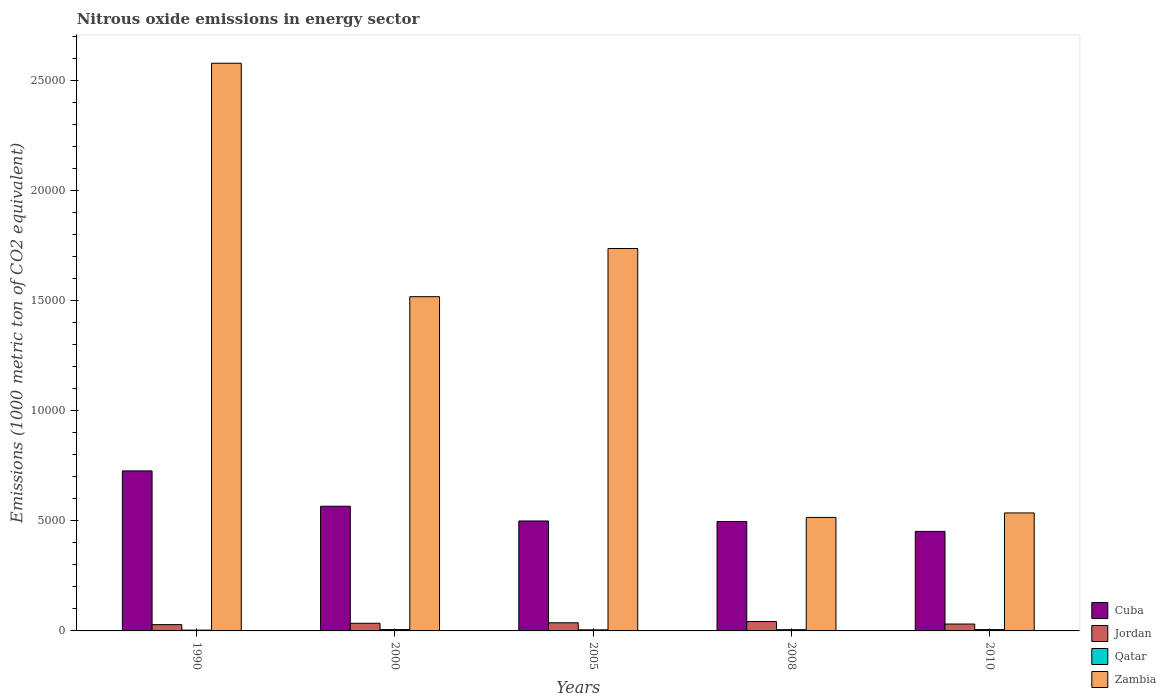How many different coloured bars are there?
Ensure brevity in your answer.  4. How many groups of bars are there?
Your answer should be compact. 5. Are the number of bars per tick equal to the number of legend labels?
Give a very brief answer. Yes. What is the label of the 2nd group of bars from the left?
Provide a short and direct response. 2000. What is the amount of nitrous oxide emitted in Cuba in 2005?
Give a very brief answer. 4992.1. Across all years, what is the maximum amount of nitrous oxide emitted in Zambia?
Provide a succinct answer. 2.58e+04. Across all years, what is the minimum amount of nitrous oxide emitted in Cuba?
Offer a very short reply. 4519.3. What is the total amount of nitrous oxide emitted in Jordan in the graph?
Your answer should be very brief. 1741.4. What is the difference between the amount of nitrous oxide emitted in Cuba in 2000 and that in 2008?
Give a very brief answer. 694.3. What is the difference between the amount of nitrous oxide emitted in Qatar in 2000 and the amount of nitrous oxide emitted in Zambia in 1990?
Provide a short and direct response. -2.57e+04. What is the average amount of nitrous oxide emitted in Qatar per year?
Offer a very short reply. 52.94. In the year 2005, what is the difference between the amount of nitrous oxide emitted in Jordan and amount of nitrous oxide emitted in Qatar?
Offer a terse response. 319.6. What is the ratio of the amount of nitrous oxide emitted in Zambia in 1990 to that in 2008?
Your answer should be compact. 5. What is the difference between the highest and the second highest amount of nitrous oxide emitted in Cuba?
Give a very brief answer. 1604.6. What is the difference between the highest and the lowest amount of nitrous oxide emitted in Cuba?
Your response must be concise. 2746.6. In how many years, is the amount of nitrous oxide emitted in Cuba greater than the average amount of nitrous oxide emitted in Cuba taken over all years?
Provide a succinct answer. 2. What does the 4th bar from the left in 2000 represents?
Ensure brevity in your answer.  Zambia. What does the 4th bar from the right in 2000 represents?
Your answer should be very brief. Cuba. How many bars are there?
Offer a very short reply. 20. Are all the bars in the graph horizontal?
Your answer should be compact. No. What is the difference between two consecutive major ticks on the Y-axis?
Provide a short and direct response. 5000. Are the values on the major ticks of Y-axis written in scientific E-notation?
Ensure brevity in your answer.  No. Where does the legend appear in the graph?
Your answer should be very brief. Bottom right. How many legend labels are there?
Make the answer very short. 4. How are the legend labels stacked?
Your response must be concise. Vertical. What is the title of the graph?
Give a very brief answer. Nitrous oxide emissions in energy sector. Does "Israel" appear as one of the legend labels in the graph?
Make the answer very short. No. What is the label or title of the Y-axis?
Keep it short and to the point. Emissions (1000 metric ton of CO2 equivalent). What is the Emissions (1000 metric ton of CO2 equivalent) in Cuba in 1990?
Your answer should be very brief. 7265.9. What is the Emissions (1000 metric ton of CO2 equivalent) of Jordan in 1990?
Make the answer very short. 285.6. What is the Emissions (1000 metric ton of CO2 equivalent) of Zambia in 1990?
Ensure brevity in your answer.  2.58e+04. What is the Emissions (1000 metric ton of CO2 equivalent) in Cuba in 2000?
Keep it short and to the point. 5661.3. What is the Emissions (1000 metric ton of CO2 equivalent) in Jordan in 2000?
Your answer should be compact. 347.2. What is the Emissions (1000 metric ton of CO2 equivalent) in Qatar in 2000?
Offer a very short reply. 61.6. What is the Emissions (1000 metric ton of CO2 equivalent) of Zambia in 2000?
Your answer should be very brief. 1.52e+04. What is the Emissions (1000 metric ton of CO2 equivalent) in Cuba in 2005?
Provide a short and direct response. 4992.1. What is the Emissions (1000 metric ton of CO2 equivalent) of Jordan in 2005?
Your answer should be very brief. 369.5. What is the Emissions (1000 metric ton of CO2 equivalent) in Qatar in 2005?
Provide a succinct answer. 49.9. What is the Emissions (1000 metric ton of CO2 equivalent) of Zambia in 2005?
Make the answer very short. 1.74e+04. What is the Emissions (1000 metric ton of CO2 equivalent) of Cuba in 2008?
Your response must be concise. 4967. What is the Emissions (1000 metric ton of CO2 equivalent) in Jordan in 2008?
Your response must be concise. 425.7. What is the Emissions (1000 metric ton of CO2 equivalent) in Qatar in 2008?
Keep it short and to the point. 56.6. What is the Emissions (1000 metric ton of CO2 equivalent) in Zambia in 2008?
Ensure brevity in your answer.  5152.9. What is the Emissions (1000 metric ton of CO2 equivalent) in Cuba in 2010?
Offer a very short reply. 4519.3. What is the Emissions (1000 metric ton of CO2 equivalent) of Jordan in 2010?
Make the answer very short. 313.4. What is the Emissions (1000 metric ton of CO2 equivalent) of Qatar in 2010?
Keep it short and to the point. 60.6. What is the Emissions (1000 metric ton of CO2 equivalent) of Zambia in 2010?
Your answer should be compact. 5357.6. Across all years, what is the maximum Emissions (1000 metric ton of CO2 equivalent) of Cuba?
Provide a short and direct response. 7265.9. Across all years, what is the maximum Emissions (1000 metric ton of CO2 equivalent) of Jordan?
Offer a terse response. 425.7. Across all years, what is the maximum Emissions (1000 metric ton of CO2 equivalent) of Qatar?
Provide a succinct answer. 61.6. Across all years, what is the maximum Emissions (1000 metric ton of CO2 equivalent) of Zambia?
Keep it short and to the point. 2.58e+04. Across all years, what is the minimum Emissions (1000 metric ton of CO2 equivalent) of Cuba?
Offer a terse response. 4519.3. Across all years, what is the minimum Emissions (1000 metric ton of CO2 equivalent) of Jordan?
Your response must be concise. 285.6. Across all years, what is the minimum Emissions (1000 metric ton of CO2 equivalent) in Qatar?
Offer a very short reply. 36. Across all years, what is the minimum Emissions (1000 metric ton of CO2 equivalent) in Zambia?
Your answer should be compact. 5152.9. What is the total Emissions (1000 metric ton of CO2 equivalent) in Cuba in the graph?
Offer a very short reply. 2.74e+04. What is the total Emissions (1000 metric ton of CO2 equivalent) of Jordan in the graph?
Offer a very short reply. 1741.4. What is the total Emissions (1000 metric ton of CO2 equivalent) of Qatar in the graph?
Give a very brief answer. 264.7. What is the total Emissions (1000 metric ton of CO2 equivalent) in Zambia in the graph?
Ensure brevity in your answer.  6.88e+04. What is the difference between the Emissions (1000 metric ton of CO2 equivalent) in Cuba in 1990 and that in 2000?
Offer a terse response. 1604.6. What is the difference between the Emissions (1000 metric ton of CO2 equivalent) in Jordan in 1990 and that in 2000?
Keep it short and to the point. -61.6. What is the difference between the Emissions (1000 metric ton of CO2 equivalent) of Qatar in 1990 and that in 2000?
Offer a terse response. -25.6. What is the difference between the Emissions (1000 metric ton of CO2 equivalent) of Zambia in 1990 and that in 2000?
Make the answer very short. 1.06e+04. What is the difference between the Emissions (1000 metric ton of CO2 equivalent) in Cuba in 1990 and that in 2005?
Your answer should be compact. 2273.8. What is the difference between the Emissions (1000 metric ton of CO2 equivalent) in Jordan in 1990 and that in 2005?
Keep it short and to the point. -83.9. What is the difference between the Emissions (1000 metric ton of CO2 equivalent) of Zambia in 1990 and that in 2005?
Ensure brevity in your answer.  8411.4. What is the difference between the Emissions (1000 metric ton of CO2 equivalent) of Cuba in 1990 and that in 2008?
Provide a short and direct response. 2298.9. What is the difference between the Emissions (1000 metric ton of CO2 equivalent) of Jordan in 1990 and that in 2008?
Provide a succinct answer. -140.1. What is the difference between the Emissions (1000 metric ton of CO2 equivalent) of Qatar in 1990 and that in 2008?
Provide a short and direct response. -20.6. What is the difference between the Emissions (1000 metric ton of CO2 equivalent) of Zambia in 1990 and that in 2008?
Your answer should be compact. 2.06e+04. What is the difference between the Emissions (1000 metric ton of CO2 equivalent) of Cuba in 1990 and that in 2010?
Provide a short and direct response. 2746.6. What is the difference between the Emissions (1000 metric ton of CO2 equivalent) of Jordan in 1990 and that in 2010?
Provide a short and direct response. -27.8. What is the difference between the Emissions (1000 metric ton of CO2 equivalent) of Qatar in 1990 and that in 2010?
Offer a terse response. -24.6. What is the difference between the Emissions (1000 metric ton of CO2 equivalent) of Zambia in 1990 and that in 2010?
Your response must be concise. 2.04e+04. What is the difference between the Emissions (1000 metric ton of CO2 equivalent) in Cuba in 2000 and that in 2005?
Make the answer very short. 669.2. What is the difference between the Emissions (1000 metric ton of CO2 equivalent) of Jordan in 2000 and that in 2005?
Ensure brevity in your answer.  -22.3. What is the difference between the Emissions (1000 metric ton of CO2 equivalent) in Zambia in 2000 and that in 2005?
Your answer should be very brief. -2187.2. What is the difference between the Emissions (1000 metric ton of CO2 equivalent) of Cuba in 2000 and that in 2008?
Offer a very short reply. 694.3. What is the difference between the Emissions (1000 metric ton of CO2 equivalent) in Jordan in 2000 and that in 2008?
Ensure brevity in your answer.  -78.5. What is the difference between the Emissions (1000 metric ton of CO2 equivalent) of Qatar in 2000 and that in 2008?
Give a very brief answer. 5. What is the difference between the Emissions (1000 metric ton of CO2 equivalent) of Zambia in 2000 and that in 2008?
Offer a very short reply. 1.00e+04. What is the difference between the Emissions (1000 metric ton of CO2 equivalent) of Cuba in 2000 and that in 2010?
Provide a succinct answer. 1142. What is the difference between the Emissions (1000 metric ton of CO2 equivalent) in Jordan in 2000 and that in 2010?
Give a very brief answer. 33.8. What is the difference between the Emissions (1000 metric ton of CO2 equivalent) in Zambia in 2000 and that in 2010?
Your answer should be very brief. 9818.5. What is the difference between the Emissions (1000 metric ton of CO2 equivalent) of Cuba in 2005 and that in 2008?
Make the answer very short. 25.1. What is the difference between the Emissions (1000 metric ton of CO2 equivalent) of Jordan in 2005 and that in 2008?
Offer a very short reply. -56.2. What is the difference between the Emissions (1000 metric ton of CO2 equivalent) in Zambia in 2005 and that in 2008?
Keep it short and to the point. 1.22e+04. What is the difference between the Emissions (1000 metric ton of CO2 equivalent) in Cuba in 2005 and that in 2010?
Provide a succinct answer. 472.8. What is the difference between the Emissions (1000 metric ton of CO2 equivalent) of Jordan in 2005 and that in 2010?
Make the answer very short. 56.1. What is the difference between the Emissions (1000 metric ton of CO2 equivalent) of Qatar in 2005 and that in 2010?
Your answer should be compact. -10.7. What is the difference between the Emissions (1000 metric ton of CO2 equivalent) of Zambia in 2005 and that in 2010?
Keep it short and to the point. 1.20e+04. What is the difference between the Emissions (1000 metric ton of CO2 equivalent) of Cuba in 2008 and that in 2010?
Provide a succinct answer. 447.7. What is the difference between the Emissions (1000 metric ton of CO2 equivalent) of Jordan in 2008 and that in 2010?
Your answer should be very brief. 112.3. What is the difference between the Emissions (1000 metric ton of CO2 equivalent) in Qatar in 2008 and that in 2010?
Your answer should be compact. -4. What is the difference between the Emissions (1000 metric ton of CO2 equivalent) in Zambia in 2008 and that in 2010?
Give a very brief answer. -204.7. What is the difference between the Emissions (1000 metric ton of CO2 equivalent) in Cuba in 1990 and the Emissions (1000 metric ton of CO2 equivalent) in Jordan in 2000?
Make the answer very short. 6918.7. What is the difference between the Emissions (1000 metric ton of CO2 equivalent) of Cuba in 1990 and the Emissions (1000 metric ton of CO2 equivalent) of Qatar in 2000?
Offer a very short reply. 7204.3. What is the difference between the Emissions (1000 metric ton of CO2 equivalent) in Cuba in 1990 and the Emissions (1000 metric ton of CO2 equivalent) in Zambia in 2000?
Your response must be concise. -7910.2. What is the difference between the Emissions (1000 metric ton of CO2 equivalent) of Jordan in 1990 and the Emissions (1000 metric ton of CO2 equivalent) of Qatar in 2000?
Make the answer very short. 224. What is the difference between the Emissions (1000 metric ton of CO2 equivalent) in Jordan in 1990 and the Emissions (1000 metric ton of CO2 equivalent) in Zambia in 2000?
Your answer should be very brief. -1.49e+04. What is the difference between the Emissions (1000 metric ton of CO2 equivalent) in Qatar in 1990 and the Emissions (1000 metric ton of CO2 equivalent) in Zambia in 2000?
Your answer should be compact. -1.51e+04. What is the difference between the Emissions (1000 metric ton of CO2 equivalent) of Cuba in 1990 and the Emissions (1000 metric ton of CO2 equivalent) of Jordan in 2005?
Provide a succinct answer. 6896.4. What is the difference between the Emissions (1000 metric ton of CO2 equivalent) of Cuba in 1990 and the Emissions (1000 metric ton of CO2 equivalent) of Qatar in 2005?
Your answer should be very brief. 7216. What is the difference between the Emissions (1000 metric ton of CO2 equivalent) in Cuba in 1990 and the Emissions (1000 metric ton of CO2 equivalent) in Zambia in 2005?
Your response must be concise. -1.01e+04. What is the difference between the Emissions (1000 metric ton of CO2 equivalent) in Jordan in 1990 and the Emissions (1000 metric ton of CO2 equivalent) in Qatar in 2005?
Your response must be concise. 235.7. What is the difference between the Emissions (1000 metric ton of CO2 equivalent) in Jordan in 1990 and the Emissions (1000 metric ton of CO2 equivalent) in Zambia in 2005?
Offer a very short reply. -1.71e+04. What is the difference between the Emissions (1000 metric ton of CO2 equivalent) in Qatar in 1990 and the Emissions (1000 metric ton of CO2 equivalent) in Zambia in 2005?
Give a very brief answer. -1.73e+04. What is the difference between the Emissions (1000 metric ton of CO2 equivalent) of Cuba in 1990 and the Emissions (1000 metric ton of CO2 equivalent) of Jordan in 2008?
Your response must be concise. 6840.2. What is the difference between the Emissions (1000 metric ton of CO2 equivalent) of Cuba in 1990 and the Emissions (1000 metric ton of CO2 equivalent) of Qatar in 2008?
Your response must be concise. 7209.3. What is the difference between the Emissions (1000 metric ton of CO2 equivalent) of Cuba in 1990 and the Emissions (1000 metric ton of CO2 equivalent) of Zambia in 2008?
Make the answer very short. 2113. What is the difference between the Emissions (1000 metric ton of CO2 equivalent) of Jordan in 1990 and the Emissions (1000 metric ton of CO2 equivalent) of Qatar in 2008?
Provide a short and direct response. 229. What is the difference between the Emissions (1000 metric ton of CO2 equivalent) of Jordan in 1990 and the Emissions (1000 metric ton of CO2 equivalent) of Zambia in 2008?
Your answer should be very brief. -4867.3. What is the difference between the Emissions (1000 metric ton of CO2 equivalent) of Qatar in 1990 and the Emissions (1000 metric ton of CO2 equivalent) of Zambia in 2008?
Provide a short and direct response. -5116.9. What is the difference between the Emissions (1000 metric ton of CO2 equivalent) of Cuba in 1990 and the Emissions (1000 metric ton of CO2 equivalent) of Jordan in 2010?
Offer a very short reply. 6952.5. What is the difference between the Emissions (1000 metric ton of CO2 equivalent) of Cuba in 1990 and the Emissions (1000 metric ton of CO2 equivalent) of Qatar in 2010?
Your answer should be very brief. 7205.3. What is the difference between the Emissions (1000 metric ton of CO2 equivalent) of Cuba in 1990 and the Emissions (1000 metric ton of CO2 equivalent) of Zambia in 2010?
Your answer should be very brief. 1908.3. What is the difference between the Emissions (1000 metric ton of CO2 equivalent) of Jordan in 1990 and the Emissions (1000 metric ton of CO2 equivalent) of Qatar in 2010?
Ensure brevity in your answer.  225. What is the difference between the Emissions (1000 metric ton of CO2 equivalent) of Jordan in 1990 and the Emissions (1000 metric ton of CO2 equivalent) of Zambia in 2010?
Make the answer very short. -5072. What is the difference between the Emissions (1000 metric ton of CO2 equivalent) in Qatar in 1990 and the Emissions (1000 metric ton of CO2 equivalent) in Zambia in 2010?
Offer a very short reply. -5321.6. What is the difference between the Emissions (1000 metric ton of CO2 equivalent) of Cuba in 2000 and the Emissions (1000 metric ton of CO2 equivalent) of Jordan in 2005?
Offer a terse response. 5291.8. What is the difference between the Emissions (1000 metric ton of CO2 equivalent) in Cuba in 2000 and the Emissions (1000 metric ton of CO2 equivalent) in Qatar in 2005?
Provide a succinct answer. 5611.4. What is the difference between the Emissions (1000 metric ton of CO2 equivalent) of Cuba in 2000 and the Emissions (1000 metric ton of CO2 equivalent) of Zambia in 2005?
Provide a succinct answer. -1.17e+04. What is the difference between the Emissions (1000 metric ton of CO2 equivalent) in Jordan in 2000 and the Emissions (1000 metric ton of CO2 equivalent) in Qatar in 2005?
Ensure brevity in your answer.  297.3. What is the difference between the Emissions (1000 metric ton of CO2 equivalent) in Jordan in 2000 and the Emissions (1000 metric ton of CO2 equivalent) in Zambia in 2005?
Offer a very short reply. -1.70e+04. What is the difference between the Emissions (1000 metric ton of CO2 equivalent) of Qatar in 2000 and the Emissions (1000 metric ton of CO2 equivalent) of Zambia in 2005?
Provide a short and direct response. -1.73e+04. What is the difference between the Emissions (1000 metric ton of CO2 equivalent) in Cuba in 2000 and the Emissions (1000 metric ton of CO2 equivalent) in Jordan in 2008?
Keep it short and to the point. 5235.6. What is the difference between the Emissions (1000 metric ton of CO2 equivalent) in Cuba in 2000 and the Emissions (1000 metric ton of CO2 equivalent) in Qatar in 2008?
Offer a terse response. 5604.7. What is the difference between the Emissions (1000 metric ton of CO2 equivalent) of Cuba in 2000 and the Emissions (1000 metric ton of CO2 equivalent) of Zambia in 2008?
Provide a succinct answer. 508.4. What is the difference between the Emissions (1000 metric ton of CO2 equivalent) in Jordan in 2000 and the Emissions (1000 metric ton of CO2 equivalent) in Qatar in 2008?
Offer a very short reply. 290.6. What is the difference between the Emissions (1000 metric ton of CO2 equivalent) of Jordan in 2000 and the Emissions (1000 metric ton of CO2 equivalent) of Zambia in 2008?
Provide a succinct answer. -4805.7. What is the difference between the Emissions (1000 metric ton of CO2 equivalent) in Qatar in 2000 and the Emissions (1000 metric ton of CO2 equivalent) in Zambia in 2008?
Your response must be concise. -5091.3. What is the difference between the Emissions (1000 metric ton of CO2 equivalent) of Cuba in 2000 and the Emissions (1000 metric ton of CO2 equivalent) of Jordan in 2010?
Give a very brief answer. 5347.9. What is the difference between the Emissions (1000 metric ton of CO2 equivalent) in Cuba in 2000 and the Emissions (1000 metric ton of CO2 equivalent) in Qatar in 2010?
Keep it short and to the point. 5600.7. What is the difference between the Emissions (1000 metric ton of CO2 equivalent) of Cuba in 2000 and the Emissions (1000 metric ton of CO2 equivalent) of Zambia in 2010?
Offer a very short reply. 303.7. What is the difference between the Emissions (1000 metric ton of CO2 equivalent) of Jordan in 2000 and the Emissions (1000 metric ton of CO2 equivalent) of Qatar in 2010?
Give a very brief answer. 286.6. What is the difference between the Emissions (1000 metric ton of CO2 equivalent) of Jordan in 2000 and the Emissions (1000 metric ton of CO2 equivalent) of Zambia in 2010?
Provide a succinct answer. -5010.4. What is the difference between the Emissions (1000 metric ton of CO2 equivalent) of Qatar in 2000 and the Emissions (1000 metric ton of CO2 equivalent) of Zambia in 2010?
Provide a succinct answer. -5296. What is the difference between the Emissions (1000 metric ton of CO2 equivalent) of Cuba in 2005 and the Emissions (1000 metric ton of CO2 equivalent) of Jordan in 2008?
Offer a very short reply. 4566.4. What is the difference between the Emissions (1000 metric ton of CO2 equivalent) of Cuba in 2005 and the Emissions (1000 metric ton of CO2 equivalent) of Qatar in 2008?
Offer a terse response. 4935.5. What is the difference between the Emissions (1000 metric ton of CO2 equivalent) of Cuba in 2005 and the Emissions (1000 metric ton of CO2 equivalent) of Zambia in 2008?
Offer a terse response. -160.8. What is the difference between the Emissions (1000 metric ton of CO2 equivalent) in Jordan in 2005 and the Emissions (1000 metric ton of CO2 equivalent) in Qatar in 2008?
Keep it short and to the point. 312.9. What is the difference between the Emissions (1000 metric ton of CO2 equivalent) in Jordan in 2005 and the Emissions (1000 metric ton of CO2 equivalent) in Zambia in 2008?
Offer a terse response. -4783.4. What is the difference between the Emissions (1000 metric ton of CO2 equivalent) of Qatar in 2005 and the Emissions (1000 metric ton of CO2 equivalent) of Zambia in 2008?
Your answer should be very brief. -5103. What is the difference between the Emissions (1000 metric ton of CO2 equivalent) of Cuba in 2005 and the Emissions (1000 metric ton of CO2 equivalent) of Jordan in 2010?
Your response must be concise. 4678.7. What is the difference between the Emissions (1000 metric ton of CO2 equivalent) in Cuba in 2005 and the Emissions (1000 metric ton of CO2 equivalent) in Qatar in 2010?
Ensure brevity in your answer.  4931.5. What is the difference between the Emissions (1000 metric ton of CO2 equivalent) of Cuba in 2005 and the Emissions (1000 metric ton of CO2 equivalent) of Zambia in 2010?
Provide a short and direct response. -365.5. What is the difference between the Emissions (1000 metric ton of CO2 equivalent) of Jordan in 2005 and the Emissions (1000 metric ton of CO2 equivalent) of Qatar in 2010?
Your answer should be very brief. 308.9. What is the difference between the Emissions (1000 metric ton of CO2 equivalent) in Jordan in 2005 and the Emissions (1000 metric ton of CO2 equivalent) in Zambia in 2010?
Make the answer very short. -4988.1. What is the difference between the Emissions (1000 metric ton of CO2 equivalent) in Qatar in 2005 and the Emissions (1000 metric ton of CO2 equivalent) in Zambia in 2010?
Provide a short and direct response. -5307.7. What is the difference between the Emissions (1000 metric ton of CO2 equivalent) of Cuba in 2008 and the Emissions (1000 metric ton of CO2 equivalent) of Jordan in 2010?
Your answer should be very brief. 4653.6. What is the difference between the Emissions (1000 metric ton of CO2 equivalent) of Cuba in 2008 and the Emissions (1000 metric ton of CO2 equivalent) of Qatar in 2010?
Your answer should be compact. 4906.4. What is the difference between the Emissions (1000 metric ton of CO2 equivalent) of Cuba in 2008 and the Emissions (1000 metric ton of CO2 equivalent) of Zambia in 2010?
Your answer should be compact. -390.6. What is the difference between the Emissions (1000 metric ton of CO2 equivalent) of Jordan in 2008 and the Emissions (1000 metric ton of CO2 equivalent) of Qatar in 2010?
Ensure brevity in your answer.  365.1. What is the difference between the Emissions (1000 metric ton of CO2 equivalent) of Jordan in 2008 and the Emissions (1000 metric ton of CO2 equivalent) of Zambia in 2010?
Make the answer very short. -4931.9. What is the difference between the Emissions (1000 metric ton of CO2 equivalent) of Qatar in 2008 and the Emissions (1000 metric ton of CO2 equivalent) of Zambia in 2010?
Ensure brevity in your answer.  -5301. What is the average Emissions (1000 metric ton of CO2 equivalent) of Cuba per year?
Make the answer very short. 5481.12. What is the average Emissions (1000 metric ton of CO2 equivalent) of Jordan per year?
Make the answer very short. 348.28. What is the average Emissions (1000 metric ton of CO2 equivalent) in Qatar per year?
Ensure brevity in your answer.  52.94. What is the average Emissions (1000 metric ton of CO2 equivalent) of Zambia per year?
Make the answer very short. 1.38e+04. In the year 1990, what is the difference between the Emissions (1000 metric ton of CO2 equivalent) in Cuba and Emissions (1000 metric ton of CO2 equivalent) in Jordan?
Provide a short and direct response. 6980.3. In the year 1990, what is the difference between the Emissions (1000 metric ton of CO2 equivalent) of Cuba and Emissions (1000 metric ton of CO2 equivalent) of Qatar?
Offer a very short reply. 7229.9. In the year 1990, what is the difference between the Emissions (1000 metric ton of CO2 equivalent) of Cuba and Emissions (1000 metric ton of CO2 equivalent) of Zambia?
Make the answer very short. -1.85e+04. In the year 1990, what is the difference between the Emissions (1000 metric ton of CO2 equivalent) in Jordan and Emissions (1000 metric ton of CO2 equivalent) in Qatar?
Offer a very short reply. 249.6. In the year 1990, what is the difference between the Emissions (1000 metric ton of CO2 equivalent) in Jordan and Emissions (1000 metric ton of CO2 equivalent) in Zambia?
Your answer should be compact. -2.55e+04. In the year 1990, what is the difference between the Emissions (1000 metric ton of CO2 equivalent) in Qatar and Emissions (1000 metric ton of CO2 equivalent) in Zambia?
Offer a terse response. -2.57e+04. In the year 2000, what is the difference between the Emissions (1000 metric ton of CO2 equivalent) of Cuba and Emissions (1000 metric ton of CO2 equivalent) of Jordan?
Your answer should be very brief. 5314.1. In the year 2000, what is the difference between the Emissions (1000 metric ton of CO2 equivalent) of Cuba and Emissions (1000 metric ton of CO2 equivalent) of Qatar?
Your answer should be compact. 5599.7. In the year 2000, what is the difference between the Emissions (1000 metric ton of CO2 equivalent) in Cuba and Emissions (1000 metric ton of CO2 equivalent) in Zambia?
Your answer should be compact. -9514.8. In the year 2000, what is the difference between the Emissions (1000 metric ton of CO2 equivalent) in Jordan and Emissions (1000 metric ton of CO2 equivalent) in Qatar?
Keep it short and to the point. 285.6. In the year 2000, what is the difference between the Emissions (1000 metric ton of CO2 equivalent) of Jordan and Emissions (1000 metric ton of CO2 equivalent) of Zambia?
Keep it short and to the point. -1.48e+04. In the year 2000, what is the difference between the Emissions (1000 metric ton of CO2 equivalent) of Qatar and Emissions (1000 metric ton of CO2 equivalent) of Zambia?
Provide a short and direct response. -1.51e+04. In the year 2005, what is the difference between the Emissions (1000 metric ton of CO2 equivalent) in Cuba and Emissions (1000 metric ton of CO2 equivalent) in Jordan?
Make the answer very short. 4622.6. In the year 2005, what is the difference between the Emissions (1000 metric ton of CO2 equivalent) in Cuba and Emissions (1000 metric ton of CO2 equivalent) in Qatar?
Offer a very short reply. 4942.2. In the year 2005, what is the difference between the Emissions (1000 metric ton of CO2 equivalent) of Cuba and Emissions (1000 metric ton of CO2 equivalent) of Zambia?
Offer a very short reply. -1.24e+04. In the year 2005, what is the difference between the Emissions (1000 metric ton of CO2 equivalent) in Jordan and Emissions (1000 metric ton of CO2 equivalent) in Qatar?
Give a very brief answer. 319.6. In the year 2005, what is the difference between the Emissions (1000 metric ton of CO2 equivalent) in Jordan and Emissions (1000 metric ton of CO2 equivalent) in Zambia?
Keep it short and to the point. -1.70e+04. In the year 2005, what is the difference between the Emissions (1000 metric ton of CO2 equivalent) of Qatar and Emissions (1000 metric ton of CO2 equivalent) of Zambia?
Make the answer very short. -1.73e+04. In the year 2008, what is the difference between the Emissions (1000 metric ton of CO2 equivalent) of Cuba and Emissions (1000 metric ton of CO2 equivalent) of Jordan?
Ensure brevity in your answer.  4541.3. In the year 2008, what is the difference between the Emissions (1000 metric ton of CO2 equivalent) of Cuba and Emissions (1000 metric ton of CO2 equivalent) of Qatar?
Give a very brief answer. 4910.4. In the year 2008, what is the difference between the Emissions (1000 metric ton of CO2 equivalent) in Cuba and Emissions (1000 metric ton of CO2 equivalent) in Zambia?
Give a very brief answer. -185.9. In the year 2008, what is the difference between the Emissions (1000 metric ton of CO2 equivalent) of Jordan and Emissions (1000 metric ton of CO2 equivalent) of Qatar?
Keep it short and to the point. 369.1. In the year 2008, what is the difference between the Emissions (1000 metric ton of CO2 equivalent) in Jordan and Emissions (1000 metric ton of CO2 equivalent) in Zambia?
Make the answer very short. -4727.2. In the year 2008, what is the difference between the Emissions (1000 metric ton of CO2 equivalent) in Qatar and Emissions (1000 metric ton of CO2 equivalent) in Zambia?
Keep it short and to the point. -5096.3. In the year 2010, what is the difference between the Emissions (1000 metric ton of CO2 equivalent) of Cuba and Emissions (1000 metric ton of CO2 equivalent) of Jordan?
Provide a short and direct response. 4205.9. In the year 2010, what is the difference between the Emissions (1000 metric ton of CO2 equivalent) in Cuba and Emissions (1000 metric ton of CO2 equivalent) in Qatar?
Keep it short and to the point. 4458.7. In the year 2010, what is the difference between the Emissions (1000 metric ton of CO2 equivalent) of Cuba and Emissions (1000 metric ton of CO2 equivalent) of Zambia?
Your answer should be very brief. -838.3. In the year 2010, what is the difference between the Emissions (1000 metric ton of CO2 equivalent) of Jordan and Emissions (1000 metric ton of CO2 equivalent) of Qatar?
Give a very brief answer. 252.8. In the year 2010, what is the difference between the Emissions (1000 metric ton of CO2 equivalent) of Jordan and Emissions (1000 metric ton of CO2 equivalent) of Zambia?
Give a very brief answer. -5044.2. In the year 2010, what is the difference between the Emissions (1000 metric ton of CO2 equivalent) of Qatar and Emissions (1000 metric ton of CO2 equivalent) of Zambia?
Give a very brief answer. -5297. What is the ratio of the Emissions (1000 metric ton of CO2 equivalent) in Cuba in 1990 to that in 2000?
Provide a short and direct response. 1.28. What is the ratio of the Emissions (1000 metric ton of CO2 equivalent) in Jordan in 1990 to that in 2000?
Provide a short and direct response. 0.82. What is the ratio of the Emissions (1000 metric ton of CO2 equivalent) in Qatar in 1990 to that in 2000?
Your answer should be very brief. 0.58. What is the ratio of the Emissions (1000 metric ton of CO2 equivalent) of Zambia in 1990 to that in 2000?
Your answer should be very brief. 1.7. What is the ratio of the Emissions (1000 metric ton of CO2 equivalent) of Cuba in 1990 to that in 2005?
Offer a very short reply. 1.46. What is the ratio of the Emissions (1000 metric ton of CO2 equivalent) of Jordan in 1990 to that in 2005?
Offer a very short reply. 0.77. What is the ratio of the Emissions (1000 metric ton of CO2 equivalent) in Qatar in 1990 to that in 2005?
Keep it short and to the point. 0.72. What is the ratio of the Emissions (1000 metric ton of CO2 equivalent) of Zambia in 1990 to that in 2005?
Your answer should be compact. 1.48. What is the ratio of the Emissions (1000 metric ton of CO2 equivalent) in Cuba in 1990 to that in 2008?
Your answer should be very brief. 1.46. What is the ratio of the Emissions (1000 metric ton of CO2 equivalent) of Jordan in 1990 to that in 2008?
Give a very brief answer. 0.67. What is the ratio of the Emissions (1000 metric ton of CO2 equivalent) in Qatar in 1990 to that in 2008?
Your answer should be compact. 0.64. What is the ratio of the Emissions (1000 metric ton of CO2 equivalent) in Zambia in 1990 to that in 2008?
Provide a short and direct response. 5. What is the ratio of the Emissions (1000 metric ton of CO2 equivalent) in Cuba in 1990 to that in 2010?
Your response must be concise. 1.61. What is the ratio of the Emissions (1000 metric ton of CO2 equivalent) of Jordan in 1990 to that in 2010?
Offer a very short reply. 0.91. What is the ratio of the Emissions (1000 metric ton of CO2 equivalent) in Qatar in 1990 to that in 2010?
Your response must be concise. 0.59. What is the ratio of the Emissions (1000 metric ton of CO2 equivalent) in Zambia in 1990 to that in 2010?
Provide a succinct answer. 4.81. What is the ratio of the Emissions (1000 metric ton of CO2 equivalent) in Cuba in 2000 to that in 2005?
Ensure brevity in your answer.  1.13. What is the ratio of the Emissions (1000 metric ton of CO2 equivalent) in Jordan in 2000 to that in 2005?
Provide a succinct answer. 0.94. What is the ratio of the Emissions (1000 metric ton of CO2 equivalent) in Qatar in 2000 to that in 2005?
Your response must be concise. 1.23. What is the ratio of the Emissions (1000 metric ton of CO2 equivalent) in Zambia in 2000 to that in 2005?
Give a very brief answer. 0.87. What is the ratio of the Emissions (1000 metric ton of CO2 equivalent) in Cuba in 2000 to that in 2008?
Offer a terse response. 1.14. What is the ratio of the Emissions (1000 metric ton of CO2 equivalent) in Jordan in 2000 to that in 2008?
Your response must be concise. 0.82. What is the ratio of the Emissions (1000 metric ton of CO2 equivalent) in Qatar in 2000 to that in 2008?
Make the answer very short. 1.09. What is the ratio of the Emissions (1000 metric ton of CO2 equivalent) of Zambia in 2000 to that in 2008?
Offer a terse response. 2.95. What is the ratio of the Emissions (1000 metric ton of CO2 equivalent) of Cuba in 2000 to that in 2010?
Your response must be concise. 1.25. What is the ratio of the Emissions (1000 metric ton of CO2 equivalent) of Jordan in 2000 to that in 2010?
Ensure brevity in your answer.  1.11. What is the ratio of the Emissions (1000 metric ton of CO2 equivalent) of Qatar in 2000 to that in 2010?
Your answer should be very brief. 1.02. What is the ratio of the Emissions (1000 metric ton of CO2 equivalent) of Zambia in 2000 to that in 2010?
Your answer should be compact. 2.83. What is the ratio of the Emissions (1000 metric ton of CO2 equivalent) in Jordan in 2005 to that in 2008?
Your answer should be compact. 0.87. What is the ratio of the Emissions (1000 metric ton of CO2 equivalent) of Qatar in 2005 to that in 2008?
Give a very brief answer. 0.88. What is the ratio of the Emissions (1000 metric ton of CO2 equivalent) of Zambia in 2005 to that in 2008?
Offer a terse response. 3.37. What is the ratio of the Emissions (1000 metric ton of CO2 equivalent) of Cuba in 2005 to that in 2010?
Provide a short and direct response. 1.1. What is the ratio of the Emissions (1000 metric ton of CO2 equivalent) in Jordan in 2005 to that in 2010?
Keep it short and to the point. 1.18. What is the ratio of the Emissions (1000 metric ton of CO2 equivalent) in Qatar in 2005 to that in 2010?
Your answer should be compact. 0.82. What is the ratio of the Emissions (1000 metric ton of CO2 equivalent) in Zambia in 2005 to that in 2010?
Offer a terse response. 3.24. What is the ratio of the Emissions (1000 metric ton of CO2 equivalent) of Cuba in 2008 to that in 2010?
Offer a very short reply. 1.1. What is the ratio of the Emissions (1000 metric ton of CO2 equivalent) in Jordan in 2008 to that in 2010?
Offer a terse response. 1.36. What is the ratio of the Emissions (1000 metric ton of CO2 equivalent) in Qatar in 2008 to that in 2010?
Your answer should be compact. 0.93. What is the ratio of the Emissions (1000 metric ton of CO2 equivalent) in Zambia in 2008 to that in 2010?
Your answer should be compact. 0.96. What is the difference between the highest and the second highest Emissions (1000 metric ton of CO2 equivalent) in Cuba?
Give a very brief answer. 1604.6. What is the difference between the highest and the second highest Emissions (1000 metric ton of CO2 equivalent) in Jordan?
Offer a very short reply. 56.2. What is the difference between the highest and the second highest Emissions (1000 metric ton of CO2 equivalent) of Zambia?
Give a very brief answer. 8411.4. What is the difference between the highest and the lowest Emissions (1000 metric ton of CO2 equivalent) of Cuba?
Keep it short and to the point. 2746.6. What is the difference between the highest and the lowest Emissions (1000 metric ton of CO2 equivalent) in Jordan?
Make the answer very short. 140.1. What is the difference between the highest and the lowest Emissions (1000 metric ton of CO2 equivalent) of Qatar?
Provide a succinct answer. 25.6. What is the difference between the highest and the lowest Emissions (1000 metric ton of CO2 equivalent) of Zambia?
Your answer should be compact. 2.06e+04. 